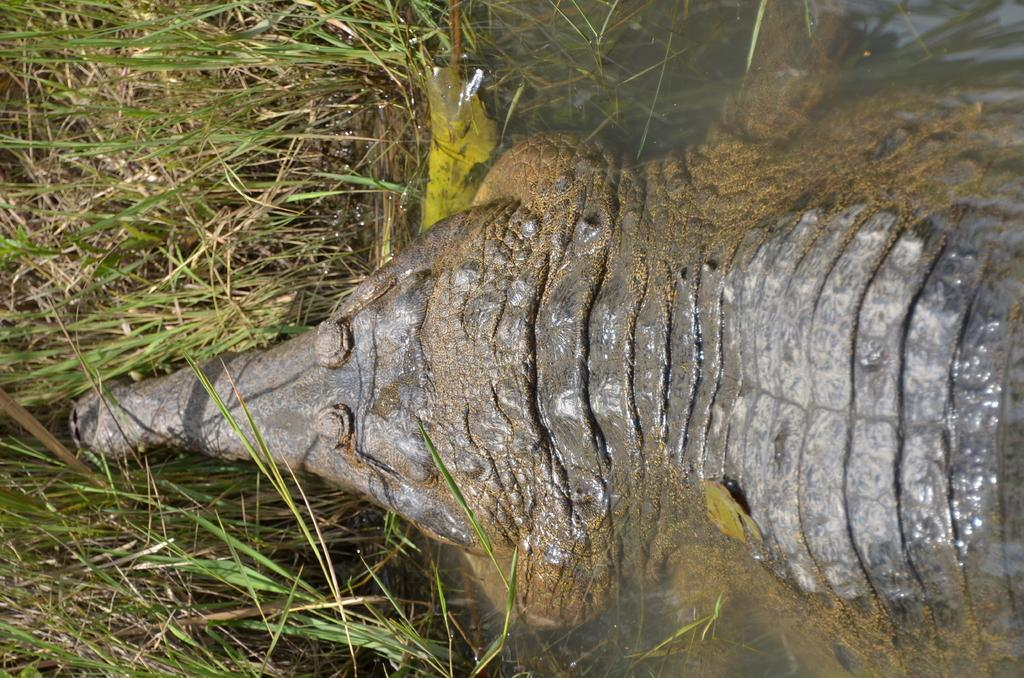What type of animal is present in the image? There is an animal in the image, but its specific type cannot be determined from the provided facts. What is the primary element visible in the image? Water is visible in the image. What type of vegetation can be seen in the image? There is grass in the image. What type of wave can be seen in the image? There is no wave present in the image; it features an animal, water, and grass. What type of fowl is visible in the image? There is no fowl present in the image; it features an animal, water, and grass, but the specific type of animal cannot be determined. 